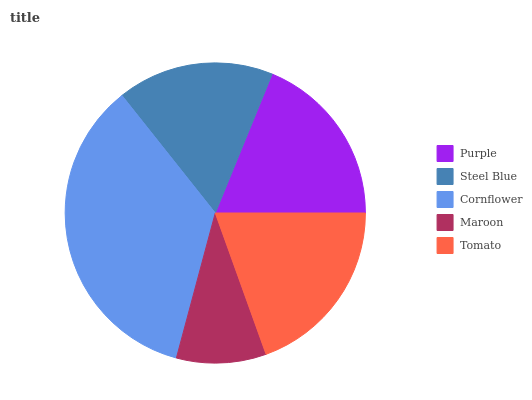Is Maroon the minimum?
Answer yes or no. Yes. Is Cornflower the maximum?
Answer yes or no. Yes. Is Steel Blue the minimum?
Answer yes or no. No. Is Steel Blue the maximum?
Answer yes or no. No. Is Purple greater than Steel Blue?
Answer yes or no. Yes. Is Steel Blue less than Purple?
Answer yes or no. Yes. Is Steel Blue greater than Purple?
Answer yes or no. No. Is Purple less than Steel Blue?
Answer yes or no. No. Is Purple the high median?
Answer yes or no. Yes. Is Purple the low median?
Answer yes or no. Yes. Is Cornflower the high median?
Answer yes or no. No. Is Steel Blue the low median?
Answer yes or no. No. 